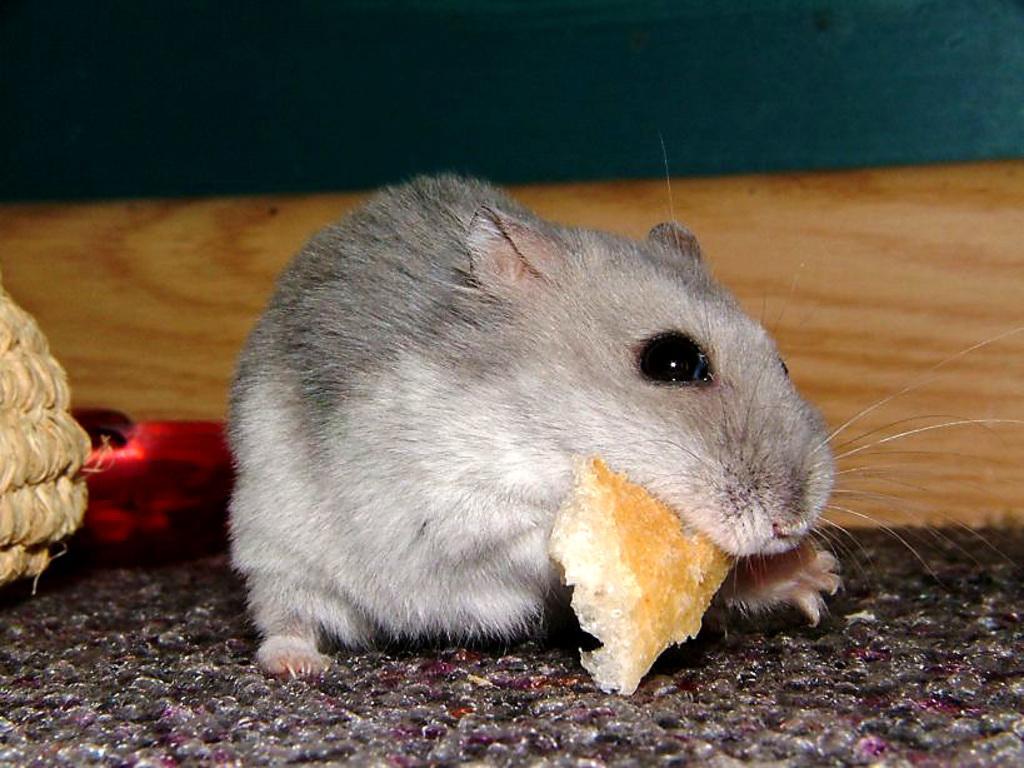Can you describe this image briefly? In this image there is a rat on the mat holding a food item and there is an object beside the rat. 